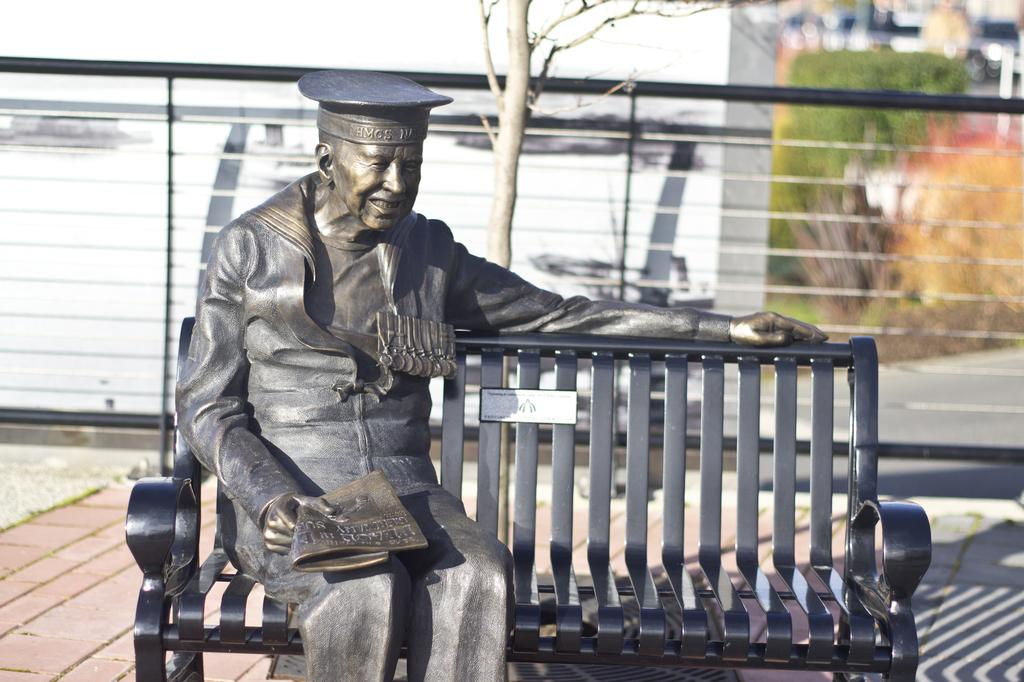What is the main subject of the image? There is a sculpture of a person in the image. What is the sculpture doing in the image? The sculpture is sitting on a bench. What can be seen in the background of the image? There is a tree and a white wall in the background of the image. What type of hair can be seen on the sculpture in the image? The sculpture does not have hair, as it is a non-living object made of a material like stone or metal. 